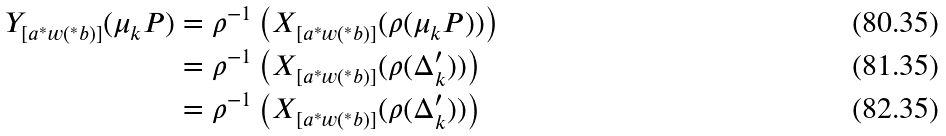Convert formula to latex. <formula><loc_0><loc_0><loc_500><loc_500>Y _ { [ a ^ { \ast } w ( ^ { \ast } b ) ] } ( \mu _ { k } P ) & = \rho ^ { - 1 } \left ( X _ { [ a ^ { \ast } w ( ^ { \ast } b ) ] } ( \rho ( \mu _ { k } P ) ) \right ) \\ & = \rho ^ { - 1 } \left ( X _ { [ a ^ { \ast } w ( ^ { \ast } b ) ] } ( \rho ( \Delta _ { k } ^ { \prime } ) ) \right ) \\ & = \rho ^ { - 1 } \left ( X _ { [ a ^ { \ast } w ( ^ { \ast } b ) ] } ( \rho ( \Delta _ { k } ^ { \prime } ) ) \right )</formula> 